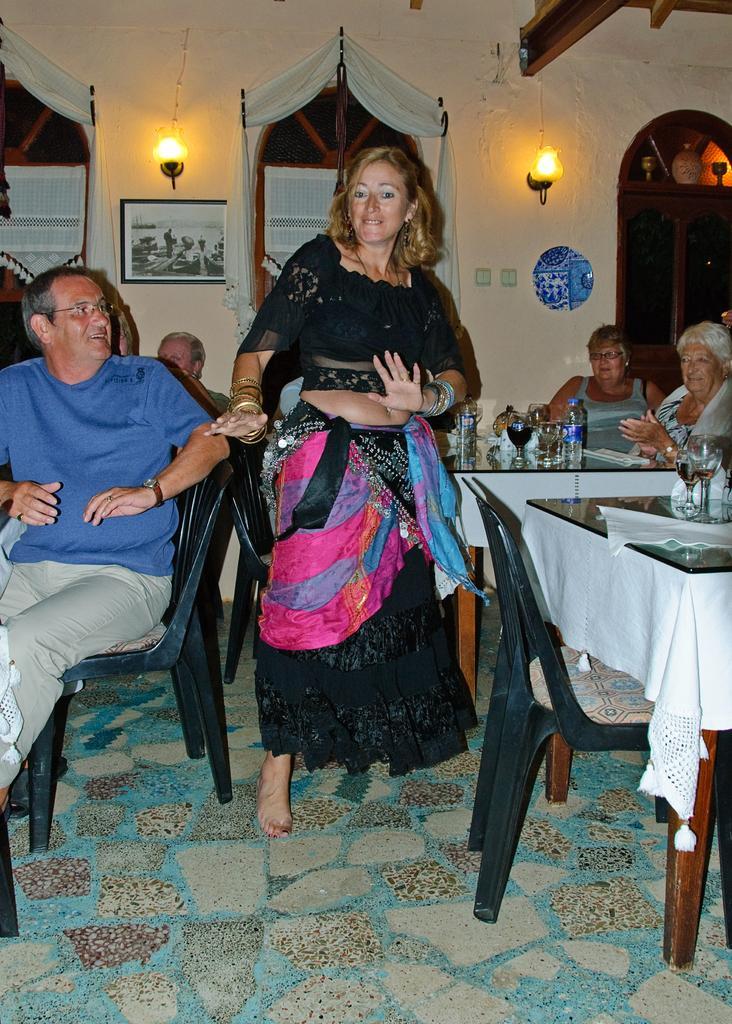Describe this image in one or two sentences. In this image I can see number of people where one woman is standing over here and rest are sitting on their chairs. I can see wall and lights on wall. Here on table I can see water bottles, glass. 